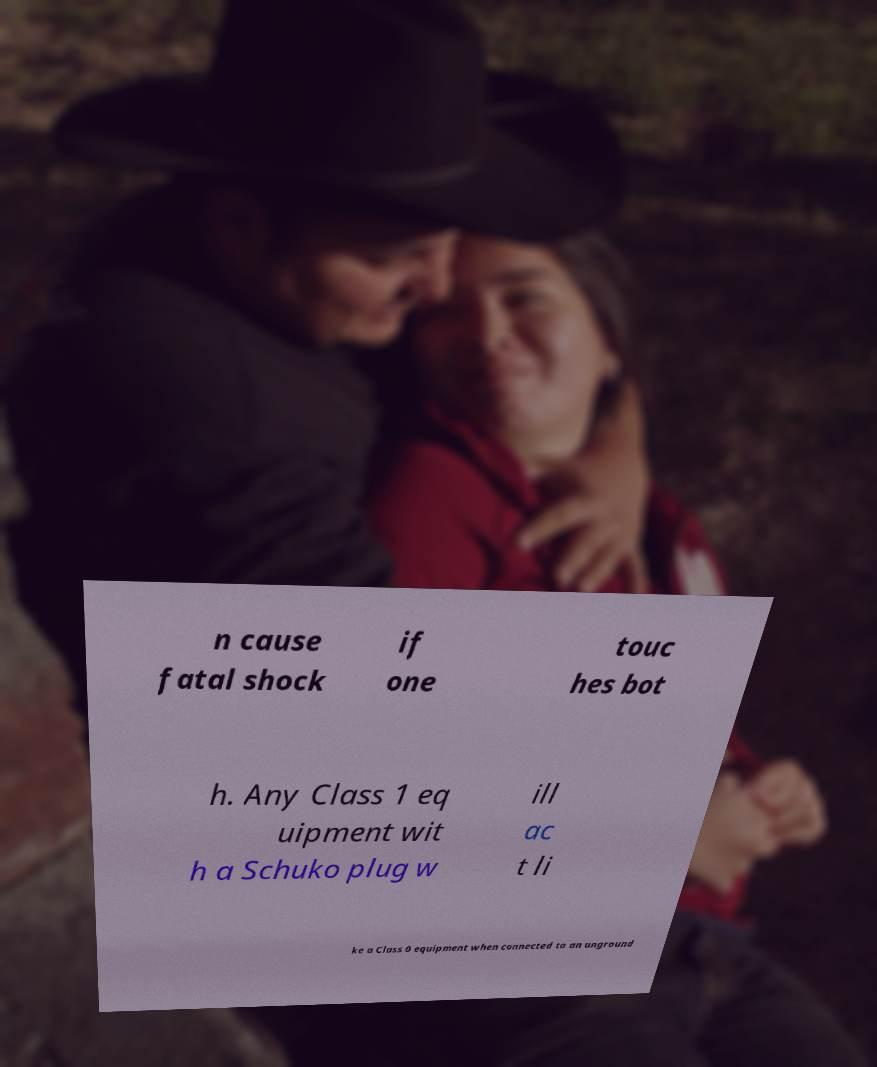Please read and relay the text visible in this image. What does it say? n cause fatal shock if one touc hes bot h. Any Class 1 eq uipment wit h a Schuko plug w ill ac t li ke a Class 0 equipment when connected to an unground 